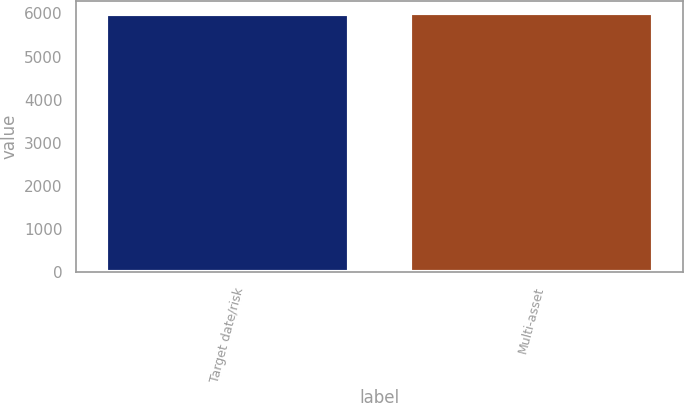<chart> <loc_0><loc_0><loc_500><loc_500><bar_chart><fcel>Target date/risk<fcel>Multi-asset<nl><fcel>5998<fcel>5998.1<nl></chart> 